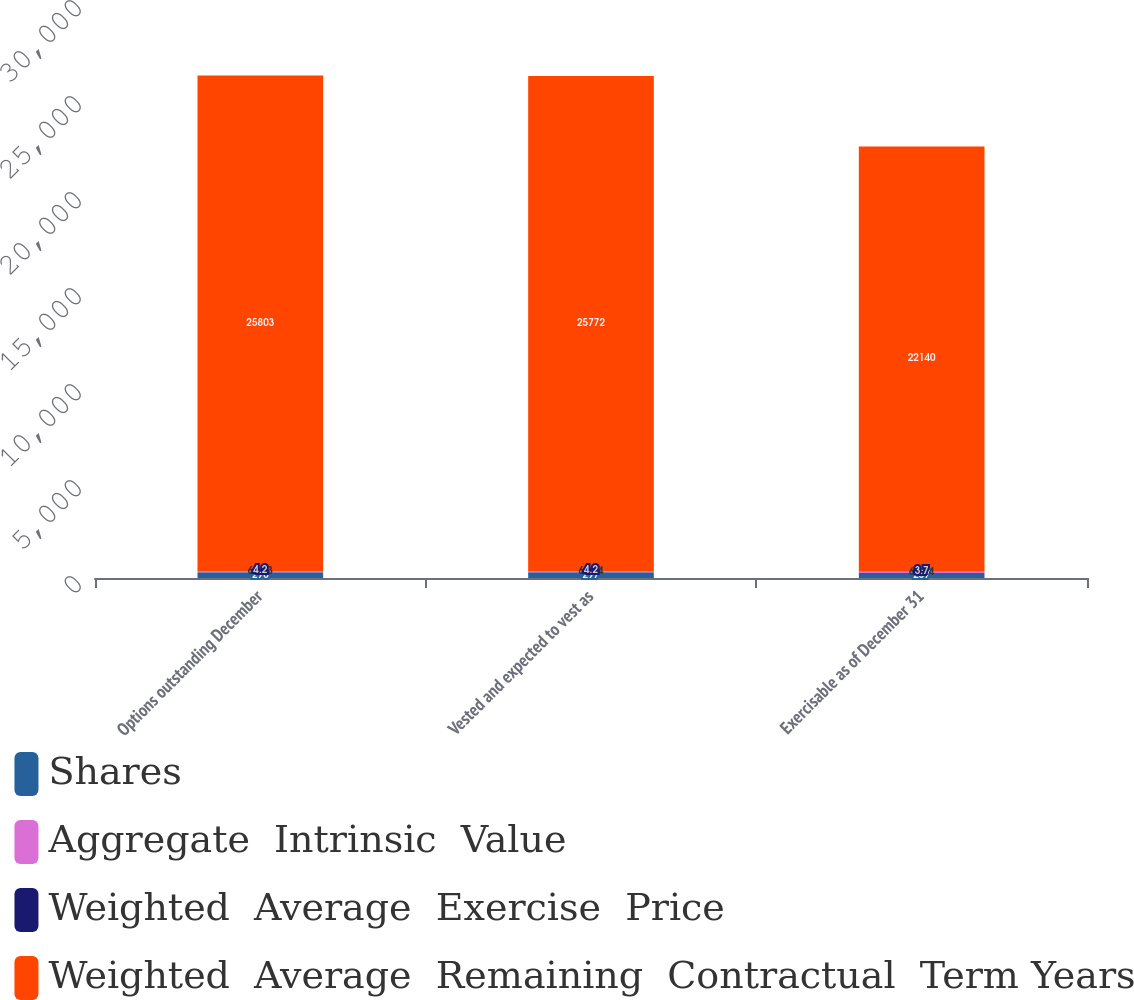Convert chart. <chart><loc_0><loc_0><loc_500><loc_500><stacked_bar_chart><ecel><fcel>Options outstanding December<fcel>Vested and expected to vest as<fcel>Exercisable as of December 31<nl><fcel>Shares<fcel>298<fcel>297<fcel>257<nl><fcel>Aggregate  Intrinsic  Value<fcel>68.63<fcel>68.64<fcel>69.24<nl><fcel>Weighted  Average  Exercise  Price<fcel>4.2<fcel>4.2<fcel>3.7<nl><fcel>Weighted  Average  Remaining  Contractual  Term Years<fcel>25803<fcel>25772<fcel>22140<nl></chart> 